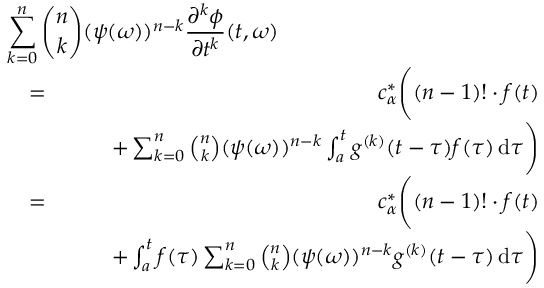<formula> <loc_0><loc_0><loc_500><loc_500>\begin{array} { r l r } { { \sum _ { k = 0 } ^ { n } \binom { n } { k } ( \psi ( \omega ) ) ^ { n - k } \frac { \partial ^ { k } \phi } { \partial t ^ { k } } ( t , \omega ) } } \\ & { = } & { c _ { \alpha } ^ { * } \left ( ( n - 1 ) ! \cdot f ( t ) } \\ & { \quad + \sum _ { k = 0 } ^ { n } \binom { n } { k } ( \psi ( \omega ) ) ^ { n - k } \int _ { a } ^ { t } g ^ { ( k ) } ( t - \tau ) f ( \tau ) \, \mathrm d \tau \right ) } \\ & { = } & { c _ { \alpha } ^ { * } \left ( ( n - 1 ) ! \cdot f ( t ) } \\ & { \quad + \int _ { a } ^ { t } f ( \tau ) \sum _ { k = 0 } ^ { n } \binom { n } { k } ( \psi ( \omega ) ) ^ { n - k } g ^ { ( k ) } ( t - \tau ) \, \mathrm d \tau \right ) } \end{array}</formula> 